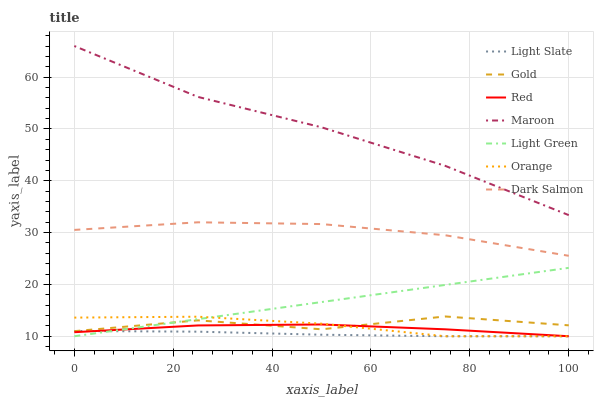Does Light Slate have the minimum area under the curve?
Answer yes or no. Yes. Does Maroon have the maximum area under the curve?
Answer yes or no. Yes. Does Dark Salmon have the minimum area under the curve?
Answer yes or no. No. Does Dark Salmon have the maximum area under the curve?
Answer yes or no. No. Is Light Green the smoothest?
Answer yes or no. Yes. Is Gold the roughest?
Answer yes or no. Yes. Is Light Slate the smoothest?
Answer yes or no. No. Is Light Slate the roughest?
Answer yes or no. No. Does Light Slate have the lowest value?
Answer yes or no. Yes. Does Dark Salmon have the lowest value?
Answer yes or no. No. Does Maroon have the highest value?
Answer yes or no. Yes. Does Dark Salmon have the highest value?
Answer yes or no. No. Is Gold less than Dark Salmon?
Answer yes or no. Yes. Is Maroon greater than Light Green?
Answer yes or no. Yes. Does Light Slate intersect Orange?
Answer yes or no. Yes. Is Light Slate less than Orange?
Answer yes or no. No. Is Light Slate greater than Orange?
Answer yes or no. No. Does Gold intersect Dark Salmon?
Answer yes or no. No. 